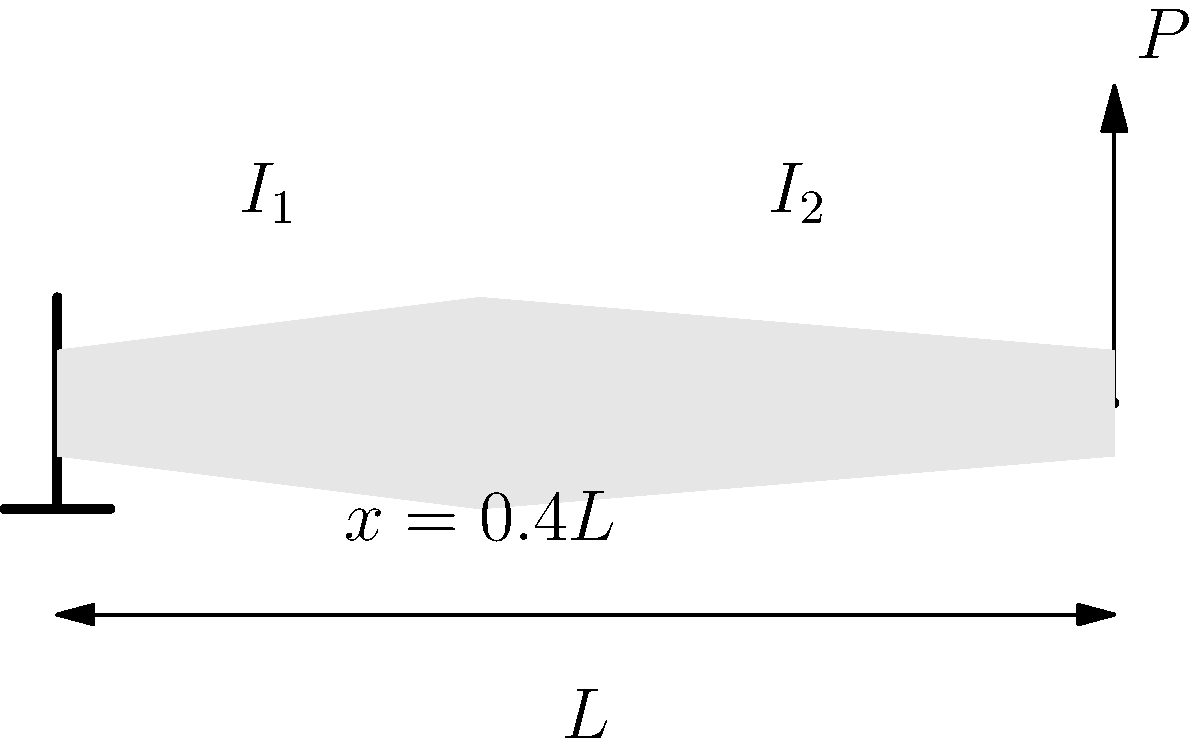A cantilever beam of length $L$ is subjected to a point load $P$ at its free end. The beam has two sections with different moments of inertia: $I_1$ for $0 \leq x < 0.4L$ and $I_2$ for $0.4L \leq x \leq L$. If $I_2 = 2I_1$ and the material's Young's modulus is $E$, determine the expression for the maximum deflection at the free end of the beam. To solve this problem, we'll follow these steps:

1) The deflection of a cantilever beam with varying cross-section can be calculated using the moment-area method.

2) The bending moment equation for a cantilever beam is:
   $M(x) = P(L-x)$

3) The curvature of the beam is given by:
   $\frac{1}{\rho} = \frac{M(x)}{EI(x)}$

4) We need to integrate the curvature twice to get the deflection:
   $\delta = \int_0^L \int_0^x \frac{M(t)}{EI(t)} dt dx$

5) We'll split this into two integrals due to the varying cross-section:
   $\delta = \int_0^{0.4L} \int_0^x \frac{P(L-t)}{EI_1} dt dx + \int_{0.4L}^L \int_0^x \frac{P(L-t)}{EI_2} dt dx$

6) Evaluating the inner integrals:
   $\delta = \frac{P}{EI_1} \int_0^{0.4L} (Lx - \frac{x^2}{2}) dx + \frac{P}{EI_2} \int_{0.4L}^L (Lx - \frac{x^2}{2}) dx$

7) Evaluating the outer integrals:
   $\delta = \frac{P}{EI_1} [0.4L^3 - \frac{(0.4L)^3}{6}] + \frac{P}{EI_2} [0.6L^3 - \frac{L^3}{2} + \frac{(0.4L)^3}{6}]$

8) Simplifying and using $I_2 = 2I_1$:
   $\delta = \frac{PL^3}{EI_1} [\frac{0.4^3}{3} + \frac{0.6^3}{6}] = \frac{PL^3}{3EI_1} [0.064 + 0.072] = \frac{0.136PL^3}{EI_1}$
Answer: $\delta = \frac{0.136PL^3}{EI_1}$ 